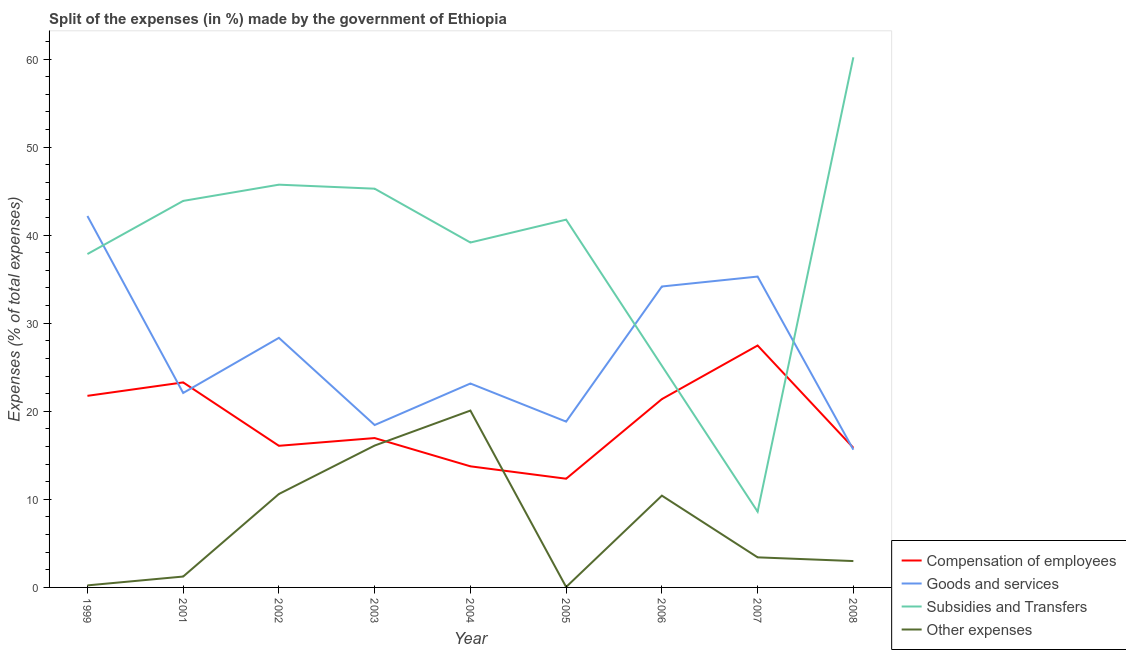Does the line corresponding to percentage of amount spent on goods and services intersect with the line corresponding to percentage of amount spent on compensation of employees?
Provide a succinct answer. Yes. Is the number of lines equal to the number of legend labels?
Your answer should be compact. Yes. What is the percentage of amount spent on compensation of employees in 2002?
Provide a succinct answer. 16.08. Across all years, what is the maximum percentage of amount spent on compensation of employees?
Provide a succinct answer. 27.47. Across all years, what is the minimum percentage of amount spent on compensation of employees?
Offer a very short reply. 12.34. What is the total percentage of amount spent on compensation of employees in the graph?
Your response must be concise. 168.87. What is the difference between the percentage of amount spent on subsidies in 2001 and that in 2004?
Offer a terse response. 4.72. What is the difference between the percentage of amount spent on compensation of employees in 2001 and the percentage of amount spent on other expenses in 2007?
Give a very brief answer. 19.86. What is the average percentage of amount spent on goods and services per year?
Give a very brief answer. 26.46. In the year 2007, what is the difference between the percentage of amount spent on compensation of employees and percentage of amount spent on goods and services?
Offer a terse response. -7.83. In how many years, is the percentage of amount spent on goods and services greater than 6 %?
Your answer should be compact. 9. What is the ratio of the percentage of amount spent on other expenses in 1999 to that in 2005?
Offer a very short reply. 4.73. What is the difference between the highest and the second highest percentage of amount spent on other expenses?
Your answer should be compact. 3.97. What is the difference between the highest and the lowest percentage of amount spent on goods and services?
Give a very brief answer. 26.53. In how many years, is the percentage of amount spent on other expenses greater than the average percentage of amount spent on other expenses taken over all years?
Offer a very short reply. 4. Is it the case that in every year, the sum of the percentage of amount spent on compensation of employees and percentage of amount spent on goods and services is greater than the percentage of amount spent on subsidies?
Your answer should be compact. No. Does the percentage of amount spent on goods and services monotonically increase over the years?
Provide a succinct answer. No. How many lines are there?
Give a very brief answer. 4. Are the values on the major ticks of Y-axis written in scientific E-notation?
Offer a very short reply. No. Does the graph contain grids?
Give a very brief answer. No. Where does the legend appear in the graph?
Make the answer very short. Bottom right. How are the legend labels stacked?
Make the answer very short. Vertical. What is the title of the graph?
Provide a succinct answer. Split of the expenses (in %) made by the government of Ethiopia. Does "Finland" appear as one of the legend labels in the graph?
Provide a succinct answer. No. What is the label or title of the X-axis?
Your response must be concise. Year. What is the label or title of the Y-axis?
Provide a short and direct response. Expenses (% of total expenses). What is the Expenses (% of total expenses) of Compensation of employees in 1999?
Provide a short and direct response. 21.75. What is the Expenses (% of total expenses) in Goods and services in 1999?
Provide a short and direct response. 42.17. What is the Expenses (% of total expenses) in Subsidies and Transfers in 1999?
Your answer should be compact. 37.85. What is the Expenses (% of total expenses) in Other expenses in 1999?
Your response must be concise. 0.23. What is the Expenses (% of total expenses) in Compensation of employees in 2001?
Your answer should be very brief. 23.28. What is the Expenses (% of total expenses) in Goods and services in 2001?
Keep it short and to the point. 22.08. What is the Expenses (% of total expenses) of Subsidies and Transfers in 2001?
Your answer should be very brief. 43.89. What is the Expenses (% of total expenses) in Other expenses in 2001?
Give a very brief answer. 1.24. What is the Expenses (% of total expenses) of Compensation of employees in 2002?
Provide a succinct answer. 16.08. What is the Expenses (% of total expenses) in Goods and services in 2002?
Make the answer very short. 28.34. What is the Expenses (% of total expenses) in Subsidies and Transfers in 2002?
Ensure brevity in your answer.  45.73. What is the Expenses (% of total expenses) in Other expenses in 2002?
Keep it short and to the point. 10.61. What is the Expenses (% of total expenses) of Compensation of employees in 2003?
Offer a very short reply. 16.96. What is the Expenses (% of total expenses) of Goods and services in 2003?
Provide a short and direct response. 18.44. What is the Expenses (% of total expenses) of Subsidies and Transfers in 2003?
Provide a succinct answer. 45.27. What is the Expenses (% of total expenses) of Other expenses in 2003?
Provide a short and direct response. 16.11. What is the Expenses (% of total expenses) of Compensation of employees in 2004?
Ensure brevity in your answer.  13.75. What is the Expenses (% of total expenses) in Goods and services in 2004?
Your response must be concise. 23.15. What is the Expenses (% of total expenses) of Subsidies and Transfers in 2004?
Provide a short and direct response. 39.16. What is the Expenses (% of total expenses) of Other expenses in 2004?
Your response must be concise. 20.08. What is the Expenses (% of total expenses) of Compensation of employees in 2005?
Give a very brief answer. 12.34. What is the Expenses (% of total expenses) in Goods and services in 2005?
Your response must be concise. 18.83. What is the Expenses (% of total expenses) of Subsidies and Transfers in 2005?
Your answer should be compact. 41.76. What is the Expenses (% of total expenses) in Other expenses in 2005?
Offer a very short reply. 0.05. What is the Expenses (% of total expenses) of Compensation of employees in 2006?
Provide a short and direct response. 21.38. What is the Expenses (% of total expenses) of Goods and services in 2006?
Provide a succinct answer. 34.17. What is the Expenses (% of total expenses) of Subsidies and Transfers in 2006?
Ensure brevity in your answer.  25.17. What is the Expenses (% of total expenses) in Other expenses in 2006?
Your answer should be very brief. 10.42. What is the Expenses (% of total expenses) of Compensation of employees in 2007?
Provide a short and direct response. 27.47. What is the Expenses (% of total expenses) of Goods and services in 2007?
Provide a short and direct response. 35.3. What is the Expenses (% of total expenses) in Subsidies and Transfers in 2007?
Your response must be concise. 8.6. What is the Expenses (% of total expenses) in Other expenses in 2007?
Offer a very short reply. 3.42. What is the Expenses (% of total expenses) in Compensation of employees in 2008?
Make the answer very short. 15.85. What is the Expenses (% of total expenses) in Goods and services in 2008?
Make the answer very short. 15.64. What is the Expenses (% of total expenses) in Subsidies and Transfers in 2008?
Your answer should be compact. 60.19. What is the Expenses (% of total expenses) of Other expenses in 2008?
Keep it short and to the point. 2.99. Across all years, what is the maximum Expenses (% of total expenses) in Compensation of employees?
Give a very brief answer. 27.47. Across all years, what is the maximum Expenses (% of total expenses) of Goods and services?
Keep it short and to the point. 42.17. Across all years, what is the maximum Expenses (% of total expenses) of Subsidies and Transfers?
Offer a very short reply. 60.19. Across all years, what is the maximum Expenses (% of total expenses) in Other expenses?
Keep it short and to the point. 20.08. Across all years, what is the minimum Expenses (% of total expenses) of Compensation of employees?
Offer a terse response. 12.34. Across all years, what is the minimum Expenses (% of total expenses) of Goods and services?
Give a very brief answer. 15.64. Across all years, what is the minimum Expenses (% of total expenses) in Subsidies and Transfers?
Your answer should be very brief. 8.6. Across all years, what is the minimum Expenses (% of total expenses) of Other expenses?
Make the answer very short. 0.05. What is the total Expenses (% of total expenses) of Compensation of employees in the graph?
Your response must be concise. 168.87. What is the total Expenses (% of total expenses) in Goods and services in the graph?
Give a very brief answer. 238.12. What is the total Expenses (% of total expenses) in Subsidies and Transfers in the graph?
Keep it short and to the point. 347.63. What is the total Expenses (% of total expenses) of Other expenses in the graph?
Give a very brief answer. 65.15. What is the difference between the Expenses (% of total expenses) of Compensation of employees in 1999 and that in 2001?
Your answer should be very brief. -1.53. What is the difference between the Expenses (% of total expenses) in Goods and services in 1999 and that in 2001?
Keep it short and to the point. 20.09. What is the difference between the Expenses (% of total expenses) of Subsidies and Transfers in 1999 and that in 2001?
Keep it short and to the point. -6.03. What is the difference between the Expenses (% of total expenses) in Other expenses in 1999 and that in 2001?
Offer a very short reply. -1. What is the difference between the Expenses (% of total expenses) of Compensation of employees in 1999 and that in 2002?
Make the answer very short. 5.67. What is the difference between the Expenses (% of total expenses) in Goods and services in 1999 and that in 2002?
Offer a terse response. 13.84. What is the difference between the Expenses (% of total expenses) of Subsidies and Transfers in 1999 and that in 2002?
Keep it short and to the point. -7.88. What is the difference between the Expenses (% of total expenses) in Other expenses in 1999 and that in 2002?
Offer a very short reply. -10.38. What is the difference between the Expenses (% of total expenses) in Compensation of employees in 1999 and that in 2003?
Your answer should be compact. 4.79. What is the difference between the Expenses (% of total expenses) in Goods and services in 1999 and that in 2003?
Give a very brief answer. 23.73. What is the difference between the Expenses (% of total expenses) in Subsidies and Transfers in 1999 and that in 2003?
Your response must be concise. -7.42. What is the difference between the Expenses (% of total expenses) of Other expenses in 1999 and that in 2003?
Offer a terse response. -15.88. What is the difference between the Expenses (% of total expenses) in Compensation of employees in 1999 and that in 2004?
Keep it short and to the point. 8. What is the difference between the Expenses (% of total expenses) in Goods and services in 1999 and that in 2004?
Keep it short and to the point. 19.02. What is the difference between the Expenses (% of total expenses) in Subsidies and Transfers in 1999 and that in 2004?
Offer a terse response. -1.31. What is the difference between the Expenses (% of total expenses) of Other expenses in 1999 and that in 2004?
Give a very brief answer. -19.85. What is the difference between the Expenses (% of total expenses) of Compensation of employees in 1999 and that in 2005?
Your answer should be compact. 9.41. What is the difference between the Expenses (% of total expenses) in Goods and services in 1999 and that in 2005?
Offer a very short reply. 23.35. What is the difference between the Expenses (% of total expenses) of Subsidies and Transfers in 1999 and that in 2005?
Ensure brevity in your answer.  -3.91. What is the difference between the Expenses (% of total expenses) of Other expenses in 1999 and that in 2005?
Provide a short and direct response. 0.18. What is the difference between the Expenses (% of total expenses) in Compensation of employees in 1999 and that in 2006?
Give a very brief answer. 0.37. What is the difference between the Expenses (% of total expenses) in Goods and services in 1999 and that in 2006?
Your response must be concise. 8. What is the difference between the Expenses (% of total expenses) of Subsidies and Transfers in 1999 and that in 2006?
Your answer should be very brief. 12.69. What is the difference between the Expenses (% of total expenses) in Other expenses in 1999 and that in 2006?
Keep it short and to the point. -10.19. What is the difference between the Expenses (% of total expenses) in Compensation of employees in 1999 and that in 2007?
Make the answer very short. -5.71. What is the difference between the Expenses (% of total expenses) of Goods and services in 1999 and that in 2007?
Your answer should be very brief. 6.88. What is the difference between the Expenses (% of total expenses) in Subsidies and Transfers in 1999 and that in 2007?
Provide a succinct answer. 29.25. What is the difference between the Expenses (% of total expenses) of Other expenses in 1999 and that in 2007?
Offer a terse response. -3.18. What is the difference between the Expenses (% of total expenses) in Compensation of employees in 1999 and that in 2008?
Your response must be concise. 5.9. What is the difference between the Expenses (% of total expenses) of Goods and services in 1999 and that in 2008?
Provide a short and direct response. 26.53. What is the difference between the Expenses (% of total expenses) of Subsidies and Transfers in 1999 and that in 2008?
Your answer should be compact. -22.34. What is the difference between the Expenses (% of total expenses) in Other expenses in 1999 and that in 2008?
Your response must be concise. -2.76. What is the difference between the Expenses (% of total expenses) of Compensation of employees in 2001 and that in 2002?
Offer a terse response. 7.2. What is the difference between the Expenses (% of total expenses) of Goods and services in 2001 and that in 2002?
Provide a succinct answer. -6.26. What is the difference between the Expenses (% of total expenses) of Subsidies and Transfers in 2001 and that in 2002?
Provide a succinct answer. -1.84. What is the difference between the Expenses (% of total expenses) in Other expenses in 2001 and that in 2002?
Give a very brief answer. -9.37. What is the difference between the Expenses (% of total expenses) of Compensation of employees in 2001 and that in 2003?
Give a very brief answer. 6.32. What is the difference between the Expenses (% of total expenses) of Goods and services in 2001 and that in 2003?
Your response must be concise. 3.64. What is the difference between the Expenses (% of total expenses) in Subsidies and Transfers in 2001 and that in 2003?
Your answer should be compact. -1.39. What is the difference between the Expenses (% of total expenses) of Other expenses in 2001 and that in 2003?
Provide a short and direct response. -14.87. What is the difference between the Expenses (% of total expenses) in Compensation of employees in 2001 and that in 2004?
Provide a succinct answer. 9.53. What is the difference between the Expenses (% of total expenses) in Goods and services in 2001 and that in 2004?
Your answer should be compact. -1.07. What is the difference between the Expenses (% of total expenses) in Subsidies and Transfers in 2001 and that in 2004?
Offer a very short reply. 4.72. What is the difference between the Expenses (% of total expenses) in Other expenses in 2001 and that in 2004?
Your response must be concise. -18.84. What is the difference between the Expenses (% of total expenses) of Compensation of employees in 2001 and that in 2005?
Your response must be concise. 10.94. What is the difference between the Expenses (% of total expenses) of Goods and services in 2001 and that in 2005?
Offer a very short reply. 3.25. What is the difference between the Expenses (% of total expenses) of Subsidies and Transfers in 2001 and that in 2005?
Give a very brief answer. 2.13. What is the difference between the Expenses (% of total expenses) in Other expenses in 2001 and that in 2005?
Offer a terse response. 1.19. What is the difference between the Expenses (% of total expenses) of Compensation of employees in 2001 and that in 2006?
Provide a short and direct response. 1.9. What is the difference between the Expenses (% of total expenses) of Goods and services in 2001 and that in 2006?
Provide a succinct answer. -12.09. What is the difference between the Expenses (% of total expenses) of Subsidies and Transfers in 2001 and that in 2006?
Provide a short and direct response. 18.72. What is the difference between the Expenses (% of total expenses) in Other expenses in 2001 and that in 2006?
Your answer should be very brief. -9.19. What is the difference between the Expenses (% of total expenses) in Compensation of employees in 2001 and that in 2007?
Offer a terse response. -4.19. What is the difference between the Expenses (% of total expenses) in Goods and services in 2001 and that in 2007?
Provide a succinct answer. -13.22. What is the difference between the Expenses (% of total expenses) in Subsidies and Transfers in 2001 and that in 2007?
Offer a terse response. 35.28. What is the difference between the Expenses (% of total expenses) in Other expenses in 2001 and that in 2007?
Make the answer very short. -2.18. What is the difference between the Expenses (% of total expenses) of Compensation of employees in 2001 and that in 2008?
Your response must be concise. 7.43. What is the difference between the Expenses (% of total expenses) of Goods and services in 2001 and that in 2008?
Provide a short and direct response. 6.44. What is the difference between the Expenses (% of total expenses) of Subsidies and Transfers in 2001 and that in 2008?
Give a very brief answer. -16.31. What is the difference between the Expenses (% of total expenses) of Other expenses in 2001 and that in 2008?
Your response must be concise. -1.76. What is the difference between the Expenses (% of total expenses) of Compensation of employees in 2002 and that in 2003?
Make the answer very short. -0.88. What is the difference between the Expenses (% of total expenses) in Goods and services in 2002 and that in 2003?
Your response must be concise. 9.9. What is the difference between the Expenses (% of total expenses) of Subsidies and Transfers in 2002 and that in 2003?
Your answer should be very brief. 0.46. What is the difference between the Expenses (% of total expenses) of Other expenses in 2002 and that in 2003?
Your answer should be very brief. -5.5. What is the difference between the Expenses (% of total expenses) in Compensation of employees in 2002 and that in 2004?
Offer a very short reply. 2.33. What is the difference between the Expenses (% of total expenses) in Goods and services in 2002 and that in 2004?
Provide a short and direct response. 5.18. What is the difference between the Expenses (% of total expenses) in Subsidies and Transfers in 2002 and that in 2004?
Your response must be concise. 6.57. What is the difference between the Expenses (% of total expenses) of Other expenses in 2002 and that in 2004?
Provide a short and direct response. -9.47. What is the difference between the Expenses (% of total expenses) in Compensation of employees in 2002 and that in 2005?
Provide a succinct answer. 3.74. What is the difference between the Expenses (% of total expenses) in Goods and services in 2002 and that in 2005?
Your answer should be very brief. 9.51. What is the difference between the Expenses (% of total expenses) of Subsidies and Transfers in 2002 and that in 2005?
Your answer should be compact. 3.97. What is the difference between the Expenses (% of total expenses) in Other expenses in 2002 and that in 2005?
Give a very brief answer. 10.56. What is the difference between the Expenses (% of total expenses) in Compensation of employees in 2002 and that in 2006?
Provide a succinct answer. -5.3. What is the difference between the Expenses (% of total expenses) in Goods and services in 2002 and that in 2006?
Your answer should be very brief. -5.83. What is the difference between the Expenses (% of total expenses) of Subsidies and Transfers in 2002 and that in 2006?
Keep it short and to the point. 20.56. What is the difference between the Expenses (% of total expenses) in Other expenses in 2002 and that in 2006?
Your response must be concise. 0.19. What is the difference between the Expenses (% of total expenses) in Compensation of employees in 2002 and that in 2007?
Make the answer very short. -11.39. What is the difference between the Expenses (% of total expenses) in Goods and services in 2002 and that in 2007?
Ensure brevity in your answer.  -6.96. What is the difference between the Expenses (% of total expenses) in Subsidies and Transfers in 2002 and that in 2007?
Your answer should be compact. 37.13. What is the difference between the Expenses (% of total expenses) in Other expenses in 2002 and that in 2007?
Offer a very short reply. 7.19. What is the difference between the Expenses (% of total expenses) of Compensation of employees in 2002 and that in 2008?
Offer a very short reply. 0.23. What is the difference between the Expenses (% of total expenses) of Goods and services in 2002 and that in 2008?
Give a very brief answer. 12.7. What is the difference between the Expenses (% of total expenses) in Subsidies and Transfers in 2002 and that in 2008?
Provide a short and direct response. -14.46. What is the difference between the Expenses (% of total expenses) of Other expenses in 2002 and that in 2008?
Your answer should be very brief. 7.62. What is the difference between the Expenses (% of total expenses) of Compensation of employees in 2003 and that in 2004?
Offer a very short reply. 3.21. What is the difference between the Expenses (% of total expenses) of Goods and services in 2003 and that in 2004?
Make the answer very short. -4.71. What is the difference between the Expenses (% of total expenses) of Subsidies and Transfers in 2003 and that in 2004?
Offer a very short reply. 6.11. What is the difference between the Expenses (% of total expenses) of Other expenses in 2003 and that in 2004?
Make the answer very short. -3.97. What is the difference between the Expenses (% of total expenses) of Compensation of employees in 2003 and that in 2005?
Your answer should be very brief. 4.62. What is the difference between the Expenses (% of total expenses) in Goods and services in 2003 and that in 2005?
Give a very brief answer. -0.39. What is the difference between the Expenses (% of total expenses) of Subsidies and Transfers in 2003 and that in 2005?
Your response must be concise. 3.51. What is the difference between the Expenses (% of total expenses) in Other expenses in 2003 and that in 2005?
Your response must be concise. 16.06. What is the difference between the Expenses (% of total expenses) in Compensation of employees in 2003 and that in 2006?
Your response must be concise. -4.42. What is the difference between the Expenses (% of total expenses) of Goods and services in 2003 and that in 2006?
Ensure brevity in your answer.  -15.73. What is the difference between the Expenses (% of total expenses) of Subsidies and Transfers in 2003 and that in 2006?
Ensure brevity in your answer.  20.11. What is the difference between the Expenses (% of total expenses) of Other expenses in 2003 and that in 2006?
Provide a succinct answer. 5.69. What is the difference between the Expenses (% of total expenses) of Compensation of employees in 2003 and that in 2007?
Provide a succinct answer. -10.51. What is the difference between the Expenses (% of total expenses) of Goods and services in 2003 and that in 2007?
Make the answer very short. -16.86. What is the difference between the Expenses (% of total expenses) in Subsidies and Transfers in 2003 and that in 2007?
Offer a terse response. 36.67. What is the difference between the Expenses (% of total expenses) in Other expenses in 2003 and that in 2007?
Provide a short and direct response. 12.69. What is the difference between the Expenses (% of total expenses) in Compensation of employees in 2003 and that in 2008?
Your response must be concise. 1.11. What is the difference between the Expenses (% of total expenses) of Goods and services in 2003 and that in 2008?
Your response must be concise. 2.8. What is the difference between the Expenses (% of total expenses) of Subsidies and Transfers in 2003 and that in 2008?
Give a very brief answer. -14.92. What is the difference between the Expenses (% of total expenses) of Other expenses in 2003 and that in 2008?
Your answer should be compact. 13.12. What is the difference between the Expenses (% of total expenses) in Compensation of employees in 2004 and that in 2005?
Keep it short and to the point. 1.41. What is the difference between the Expenses (% of total expenses) in Goods and services in 2004 and that in 2005?
Give a very brief answer. 4.33. What is the difference between the Expenses (% of total expenses) in Subsidies and Transfers in 2004 and that in 2005?
Ensure brevity in your answer.  -2.6. What is the difference between the Expenses (% of total expenses) in Other expenses in 2004 and that in 2005?
Your answer should be very brief. 20.03. What is the difference between the Expenses (% of total expenses) of Compensation of employees in 2004 and that in 2006?
Keep it short and to the point. -7.63. What is the difference between the Expenses (% of total expenses) in Goods and services in 2004 and that in 2006?
Your answer should be very brief. -11.02. What is the difference between the Expenses (% of total expenses) of Subsidies and Transfers in 2004 and that in 2006?
Make the answer very short. 14. What is the difference between the Expenses (% of total expenses) in Other expenses in 2004 and that in 2006?
Give a very brief answer. 9.66. What is the difference between the Expenses (% of total expenses) in Compensation of employees in 2004 and that in 2007?
Make the answer very short. -13.72. What is the difference between the Expenses (% of total expenses) of Goods and services in 2004 and that in 2007?
Your answer should be very brief. -12.14. What is the difference between the Expenses (% of total expenses) of Subsidies and Transfers in 2004 and that in 2007?
Make the answer very short. 30.56. What is the difference between the Expenses (% of total expenses) of Other expenses in 2004 and that in 2007?
Your response must be concise. 16.66. What is the difference between the Expenses (% of total expenses) of Compensation of employees in 2004 and that in 2008?
Offer a terse response. -2.1. What is the difference between the Expenses (% of total expenses) in Goods and services in 2004 and that in 2008?
Provide a succinct answer. 7.51. What is the difference between the Expenses (% of total expenses) of Subsidies and Transfers in 2004 and that in 2008?
Ensure brevity in your answer.  -21.03. What is the difference between the Expenses (% of total expenses) in Other expenses in 2004 and that in 2008?
Provide a succinct answer. 17.09. What is the difference between the Expenses (% of total expenses) of Compensation of employees in 2005 and that in 2006?
Offer a terse response. -9.04. What is the difference between the Expenses (% of total expenses) in Goods and services in 2005 and that in 2006?
Offer a terse response. -15.34. What is the difference between the Expenses (% of total expenses) of Subsidies and Transfers in 2005 and that in 2006?
Make the answer very short. 16.59. What is the difference between the Expenses (% of total expenses) in Other expenses in 2005 and that in 2006?
Your answer should be compact. -10.37. What is the difference between the Expenses (% of total expenses) in Compensation of employees in 2005 and that in 2007?
Your answer should be compact. -15.13. What is the difference between the Expenses (% of total expenses) of Goods and services in 2005 and that in 2007?
Offer a very short reply. -16.47. What is the difference between the Expenses (% of total expenses) in Subsidies and Transfers in 2005 and that in 2007?
Make the answer very short. 33.15. What is the difference between the Expenses (% of total expenses) of Other expenses in 2005 and that in 2007?
Make the answer very short. -3.37. What is the difference between the Expenses (% of total expenses) in Compensation of employees in 2005 and that in 2008?
Make the answer very short. -3.51. What is the difference between the Expenses (% of total expenses) in Goods and services in 2005 and that in 2008?
Give a very brief answer. 3.19. What is the difference between the Expenses (% of total expenses) in Subsidies and Transfers in 2005 and that in 2008?
Your response must be concise. -18.43. What is the difference between the Expenses (% of total expenses) of Other expenses in 2005 and that in 2008?
Your answer should be very brief. -2.94. What is the difference between the Expenses (% of total expenses) in Compensation of employees in 2006 and that in 2007?
Offer a very short reply. -6.09. What is the difference between the Expenses (% of total expenses) of Goods and services in 2006 and that in 2007?
Offer a very short reply. -1.13. What is the difference between the Expenses (% of total expenses) of Subsidies and Transfers in 2006 and that in 2007?
Your answer should be very brief. 16.56. What is the difference between the Expenses (% of total expenses) in Other expenses in 2006 and that in 2007?
Provide a succinct answer. 7.01. What is the difference between the Expenses (% of total expenses) of Compensation of employees in 2006 and that in 2008?
Give a very brief answer. 5.53. What is the difference between the Expenses (% of total expenses) in Goods and services in 2006 and that in 2008?
Offer a terse response. 18.53. What is the difference between the Expenses (% of total expenses) of Subsidies and Transfers in 2006 and that in 2008?
Provide a succinct answer. -35.03. What is the difference between the Expenses (% of total expenses) in Other expenses in 2006 and that in 2008?
Offer a terse response. 7.43. What is the difference between the Expenses (% of total expenses) of Compensation of employees in 2007 and that in 2008?
Your response must be concise. 11.62. What is the difference between the Expenses (% of total expenses) in Goods and services in 2007 and that in 2008?
Keep it short and to the point. 19.65. What is the difference between the Expenses (% of total expenses) in Subsidies and Transfers in 2007 and that in 2008?
Make the answer very short. -51.59. What is the difference between the Expenses (% of total expenses) in Other expenses in 2007 and that in 2008?
Your answer should be compact. 0.42. What is the difference between the Expenses (% of total expenses) in Compensation of employees in 1999 and the Expenses (% of total expenses) in Goods and services in 2001?
Your response must be concise. -0.33. What is the difference between the Expenses (% of total expenses) of Compensation of employees in 1999 and the Expenses (% of total expenses) of Subsidies and Transfers in 2001?
Your answer should be very brief. -22.13. What is the difference between the Expenses (% of total expenses) of Compensation of employees in 1999 and the Expenses (% of total expenses) of Other expenses in 2001?
Your answer should be compact. 20.52. What is the difference between the Expenses (% of total expenses) of Goods and services in 1999 and the Expenses (% of total expenses) of Subsidies and Transfers in 2001?
Ensure brevity in your answer.  -1.71. What is the difference between the Expenses (% of total expenses) in Goods and services in 1999 and the Expenses (% of total expenses) in Other expenses in 2001?
Your answer should be compact. 40.94. What is the difference between the Expenses (% of total expenses) of Subsidies and Transfers in 1999 and the Expenses (% of total expenses) of Other expenses in 2001?
Your response must be concise. 36.62. What is the difference between the Expenses (% of total expenses) of Compensation of employees in 1999 and the Expenses (% of total expenses) of Goods and services in 2002?
Ensure brevity in your answer.  -6.58. What is the difference between the Expenses (% of total expenses) in Compensation of employees in 1999 and the Expenses (% of total expenses) in Subsidies and Transfers in 2002?
Offer a terse response. -23.98. What is the difference between the Expenses (% of total expenses) of Compensation of employees in 1999 and the Expenses (% of total expenses) of Other expenses in 2002?
Your response must be concise. 11.15. What is the difference between the Expenses (% of total expenses) in Goods and services in 1999 and the Expenses (% of total expenses) in Subsidies and Transfers in 2002?
Your answer should be very brief. -3.56. What is the difference between the Expenses (% of total expenses) of Goods and services in 1999 and the Expenses (% of total expenses) of Other expenses in 2002?
Offer a very short reply. 31.56. What is the difference between the Expenses (% of total expenses) in Subsidies and Transfers in 1999 and the Expenses (% of total expenses) in Other expenses in 2002?
Your answer should be compact. 27.24. What is the difference between the Expenses (% of total expenses) of Compensation of employees in 1999 and the Expenses (% of total expenses) of Goods and services in 2003?
Ensure brevity in your answer.  3.31. What is the difference between the Expenses (% of total expenses) of Compensation of employees in 1999 and the Expenses (% of total expenses) of Subsidies and Transfers in 2003?
Make the answer very short. -23.52. What is the difference between the Expenses (% of total expenses) of Compensation of employees in 1999 and the Expenses (% of total expenses) of Other expenses in 2003?
Your answer should be very brief. 5.64. What is the difference between the Expenses (% of total expenses) in Goods and services in 1999 and the Expenses (% of total expenses) in Subsidies and Transfers in 2003?
Your response must be concise. -3.1. What is the difference between the Expenses (% of total expenses) in Goods and services in 1999 and the Expenses (% of total expenses) in Other expenses in 2003?
Provide a succinct answer. 26.06. What is the difference between the Expenses (% of total expenses) in Subsidies and Transfers in 1999 and the Expenses (% of total expenses) in Other expenses in 2003?
Offer a very short reply. 21.74. What is the difference between the Expenses (% of total expenses) of Compensation of employees in 1999 and the Expenses (% of total expenses) of Subsidies and Transfers in 2004?
Your answer should be very brief. -17.41. What is the difference between the Expenses (% of total expenses) of Compensation of employees in 1999 and the Expenses (% of total expenses) of Other expenses in 2004?
Give a very brief answer. 1.67. What is the difference between the Expenses (% of total expenses) of Goods and services in 1999 and the Expenses (% of total expenses) of Subsidies and Transfers in 2004?
Offer a very short reply. 3.01. What is the difference between the Expenses (% of total expenses) in Goods and services in 1999 and the Expenses (% of total expenses) in Other expenses in 2004?
Offer a very short reply. 22.09. What is the difference between the Expenses (% of total expenses) of Subsidies and Transfers in 1999 and the Expenses (% of total expenses) of Other expenses in 2004?
Keep it short and to the point. 17.77. What is the difference between the Expenses (% of total expenses) in Compensation of employees in 1999 and the Expenses (% of total expenses) in Goods and services in 2005?
Ensure brevity in your answer.  2.93. What is the difference between the Expenses (% of total expenses) of Compensation of employees in 1999 and the Expenses (% of total expenses) of Subsidies and Transfers in 2005?
Make the answer very short. -20.01. What is the difference between the Expenses (% of total expenses) in Compensation of employees in 1999 and the Expenses (% of total expenses) in Other expenses in 2005?
Give a very brief answer. 21.7. What is the difference between the Expenses (% of total expenses) of Goods and services in 1999 and the Expenses (% of total expenses) of Subsidies and Transfers in 2005?
Offer a very short reply. 0.41. What is the difference between the Expenses (% of total expenses) in Goods and services in 1999 and the Expenses (% of total expenses) in Other expenses in 2005?
Your answer should be compact. 42.12. What is the difference between the Expenses (% of total expenses) in Subsidies and Transfers in 1999 and the Expenses (% of total expenses) in Other expenses in 2005?
Your response must be concise. 37.8. What is the difference between the Expenses (% of total expenses) of Compensation of employees in 1999 and the Expenses (% of total expenses) of Goods and services in 2006?
Give a very brief answer. -12.42. What is the difference between the Expenses (% of total expenses) of Compensation of employees in 1999 and the Expenses (% of total expenses) of Subsidies and Transfers in 2006?
Give a very brief answer. -3.41. What is the difference between the Expenses (% of total expenses) of Compensation of employees in 1999 and the Expenses (% of total expenses) of Other expenses in 2006?
Give a very brief answer. 11.33. What is the difference between the Expenses (% of total expenses) in Goods and services in 1999 and the Expenses (% of total expenses) in Subsidies and Transfers in 2006?
Offer a terse response. 17.01. What is the difference between the Expenses (% of total expenses) of Goods and services in 1999 and the Expenses (% of total expenses) of Other expenses in 2006?
Provide a short and direct response. 31.75. What is the difference between the Expenses (% of total expenses) in Subsidies and Transfers in 1999 and the Expenses (% of total expenses) in Other expenses in 2006?
Provide a short and direct response. 27.43. What is the difference between the Expenses (% of total expenses) in Compensation of employees in 1999 and the Expenses (% of total expenses) in Goods and services in 2007?
Offer a terse response. -13.54. What is the difference between the Expenses (% of total expenses) in Compensation of employees in 1999 and the Expenses (% of total expenses) in Subsidies and Transfers in 2007?
Provide a succinct answer. 13.15. What is the difference between the Expenses (% of total expenses) of Compensation of employees in 1999 and the Expenses (% of total expenses) of Other expenses in 2007?
Offer a terse response. 18.34. What is the difference between the Expenses (% of total expenses) of Goods and services in 1999 and the Expenses (% of total expenses) of Subsidies and Transfers in 2007?
Provide a short and direct response. 33.57. What is the difference between the Expenses (% of total expenses) of Goods and services in 1999 and the Expenses (% of total expenses) of Other expenses in 2007?
Ensure brevity in your answer.  38.76. What is the difference between the Expenses (% of total expenses) in Subsidies and Transfers in 1999 and the Expenses (% of total expenses) in Other expenses in 2007?
Offer a very short reply. 34.44. What is the difference between the Expenses (% of total expenses) of Compensation of employees in 1999 and the Expenses (% of total expenses) of Goods and services in 2008?
Offer a terse response. 6.11. What is the difference between the Expenses (% of total expenses) of Compensation of employees in 1999 and the Expenses (% of total expenses) of Subsidies and Transfers in 2008?
Keep it short and to the point. -38.44. What is the difference between the Expenses (% of total expenses) of Compensation of employees in 1999 and the Expenses (% of total expenses) of Other expenses in 2008?
Offer a terse response. 18.76. What is the difference between the Expenses (% of total expenses) in Goods and services in 1999 and the Expenses (% of total expenses) in Subsidies and Transfers in 2008?
Provide a short and direct response. -18.02. What is the difference between the Expenses (% of total expenses) in Goods and services in 1999 and the Expenses (% of total expenses) in Other expenses in 2008?
Provide a short and direct response. 39.18. What is the difference between the Expenses (% of total expenses) in Subsidies and Transfers in 1999 and the Expenses (% of total expenses) in Other expenses in 2008?
Offer a very short reply. 34.86. What is the difference between the Expenses (% of total expenses) in Compensation of employees in 2001 and the Expenses (% of total expenses) in Goods and services in 2002?
Keep it short and to the point. -5.06. What is the difference between the Expenses (% of total expenses) in Compensation of employees in 2001 and the Expenses (% of total expenses) in Subsidies and Transfers in 2002?
Provide a short and direct response. -22.45. What is the difference between the Expenses (% of total expenses) in Compensation of employees in 2001 and the Expenses (% of total expenses) in Other expenses in 2002?
Provide a short and direct response. 12.67. What is the difference between the Expenses (% of total expenses) of Goods and services in 2001 and the Expenses (% of total expenses) of Subsidies and Transfers in 2002?
Provide a short and direct response. -23.65. What is the difference between the Expenses (% of total expenses) in Goods and services in 2001 and the Expenses (% of total expenses) in Other expenses in 2002?
Your answer should be compact. 11.47. What is the difference between the Expenses (% of total expenses) of Subsidies and Transfers in 2001 and the Expenses (% of total expenses) of Other expenses in 2002?
Provide a succinct answer. 33.28. What is the difference between the Expenses (% of total expenses) in Compensation of employees in 2001 and the Expenses (% of total expenses) in Goods and services in 2003?
Give a very brief answer. 4.84. What is the difference between the Expenses (% of total expenses) in Compensation of employees in 2001 and the Expenses (% of total expenses) in Subsidies and Transfers in 2003?
Make the answer very short. -22. What is the difference between the Expenses (% of total expenses) in Compensation of employees in 2001 and the Expenses (% of total expenses) in Other expenses in 2003?
Provide a short and direct response. 7.17. What is the difference between the Expenses (% of total expenses) in Goods and services in 2001 and the Expenses (% of total expenses) in Subsidies and Transfers in 2003?
Keep it short and to the point. -23.2. What is the difference between the Expenses (% of total expenses) of Goods and services in 2001 and the Expenses (% of total expenses) of Other expenses in 2003?
Give a very brief answer. 5.97. What is the difference between the Expenses (% of total expenses) in Subsidies and Transfers in 2001 and the Expenses (% of total expenses) in Other expenses in 2003?
Ensure brevity in your answer.  27.78. What is the difference between the Expenses (% of total expenses) of Compensation of employees in 2001 and the Expenses (% of total expenses) of Goods and services in 2004?
Your answer should be very brief. 0.13. What is the difference between the Expenses (% of total expenses) in Compensation of employees in 2001 and the Expenses (% of total expenses) in Subsidies and Transfers in 2004?
Keep it short and to the point. -15.88. What is the difference between the Expenses (% of total expenses) in Compensation of employees in 2001 and the Expenses (% of total expenses) in Other expenses in 2004?
Offer a very short reply. 3.2. What is the difference between the Expenses (% of total expenses) in Goods and services in 2001 and the Expenses (% of total expenses) in Subsidies and Transfers in 2004?
Your answer should be very brief. -17.08. What is the difference between the Expenses (% of total expenses) in Goods and services in 2001 and the Expenses (% of total expenses) in Other expenses in 2004?
Your answer should be compact. 2. What is the difference between the Expenses (% of total expenses) of Subsidies and Transfers in 2001 and the Expenses (% of total expenses) of Other expenses in 2004?
Your response must be concise. 23.81. What is the difference between the Expenses (% of total expenses) in Compensation of employees in 2001 and the Expenses (% of total expenses) in Goods and services in 2005?
Keep it short and to the point. 4.45. What is the difference between the Expenses (% of total expenses) in Compensation of employees in 2001 and the Expenses (% of total expenses) in Subsidies and Transfers in 2005?
Provide a succinct answer. -18.48. What is the difference between the Expenses (% of total expenses) of Compensation of employees in 2001 and the Expenses (% of total expenses) of Other expenses in 2005?
Offer a very short reply. 23.23. What is the difference between the Expenses (% of total expenses) in Goods and services in 2001 and the Expenses (% of total expenses) in Subsidies and Transfers in 2005?
Keep it short and to the point. -19.68. What is the difference between the Expenses (% of total expenses) in Goods and services in 2001 and the Expenses (% of total expenses) in Other expenses in 2005?
Give a very brief answer. 22.03. What is the difference between the Expenses (% of total expenses) in Subsidies and Transfers in 2001 and the Expenses (% of total expenses) in Other expenses in 2005?
Your answer should be compact. 43.84. What is the difference between the Expenses (% of total expenses) of Compensation of employees in 2001 and the Expenses (% of total expenses) of Goods and services in 2006?
Give a very brief answer. -10.89. What is the difference between the Expenses (% of total expenses) in Compensation of employees in 2001 and the Expenses (% of total expenses) in Subsidies and Transfers in 2006?
Make the answer very short. -1.89. What is the difference between the Expenses (% of total expenses) in Compensation of employees in 2001 and the Expenses (% of total expenses) in Other expenses in 2006?
Ensure brevity in your answer.  12.86. What is the difference between the Expenses (% of total expenses) in Goods and services in 2001 and the Expenses (% of total expenses) in Subsidies and Transfers in 2006?
Make the answer very short. -3.09. What is the difference between the Expenses (% of total expenses) of Goods and services in 2001 and the Expenses (% of total expenses) of Other expenses in 2006?
Provide a succinct answer. 11.66. What is the difference between the Expenses (% of total expenses) of Subsidies and Transfers in 2001 and the Expenses (% of total expenses) of Other expenses in 2006?
Make the answer very short. 33.47. What is the difference between the Expenses (% of total expenses) of Compensation of employees in 2001 and the Expenses (% of total expenses) of Goods and services in 2007?
Ensure brevity in your answer.  -12.02. What is the difference between the Expenses (% of total expenses) of Compensation of employees in 2001 and the Expenses (% of total expenses) of Subsidies and Transfers in 2007?
Offer a very short reply. 14.67. What is the difference between the Expenses (% of total expenses) of Compensation of employees in 2001 and the Expenses (% of total expenses) of Other expenses in 2007?
Ensure brevity in your answer.  19.86. What is the difference between the Expenses (% of total expenses) of Goods and services in 2001 and the Expenses (% of total expenses) of Subsidies and Transfers in 2007?
Ensure brevity in your answer.  13.47. What is the difference between the Expenses (% of total expenses) in Goods and services in 2001 and the Expenses (% of total expenses) in Other expenses in 2007?
Provide a succinct answer. 18.66. What is the difference between the Expenses (% of total expenses) in Subsidies and Transfers in 2001 and the Expenses (% of total expenses) in Other expenses in 2007?
Provide a short and direct response. 40.47. What is the difference between the Expenses (% of total expenses) of Compensation of employees in 2001 and the Expenses (% of total expenses) of Goods and services in 2008?
Make the answer very short. 7.64. What is the difference between the Expenses (% of total expenses) in Compensation of employees in 2001 and the Expenses (% of total expenses) in Subsidies and Transfers in 2008?
Give a very brief answer. -36.91. What is the difference between the Expenses (% of total expenses) of Compensation of employees in 2001 and the Expenses (% of total expenses) of Other expenses in 2008?
Provide a succinct answer. 20.29. What is the difference between the Expenses (% of total expenses) of Goods and services in 2001 and the Expenses (% of total expenses) of Subsidies and Transfers in 2008?
Ensure brevity in your answer.  -38.11. What is the difference between the Expenses (% of total expenses) of Goods and services in 2001 and the Expenses (% of total expenses) of Other expenses in 2008?
Make the answer very short. 19.09. What is the difference between the Expenses (% of total expenses) in Subsidies and Transfers in 2001 and the Expenses (% of total expenses) in Other expenses in 2008?
Your answer should be compact. 40.89. What is the difference between the Expenses (% of total expenses) in Compensation of employees in 2002 and the Expenses (% of total expenses) in Goods and services in 2003?
Keep it short and to the point. -2.36. What is the difference between the Expenses (% of total expenses) in Compensation of employees in 2002 and the Expenses (% of total expenses) in Subsidies and Transfers in 2003?
Your response must be concise. -29.19. What is the difference between the Expenses (% of total expenses) in Compensation of employees in 2002 and the Expenses (% of total expenses) in Other expenses in 2003?
Your response must be concise. -0.03. What is the difference between the Expenses (% of total expenses) of Goods and services in 2002 and the Expenses (% of total expenses) of Subsidies and Transfers in 2003?
Offer a very short reply. -16.94. What is the difference between the Expenses (% of total expenses) in Goods and services in 2002 and the Expenses (% of total expenses) in Other expenses in 2003?
Your answer should be compact. 12.23. What is the difference between the Expenses (% of total expenses) of Subsidies and Transfers in 2002 and the Expenses (% of total expenses) of Other expenses in 2003?
Give a very brief answer. 29.62. What is the difference between the Expenses (% of total expenses) of Compensation of employees in 2002 and the Expenses (% of total expenses) of Goods and services in 2004?
Provide a succinct answer. -7.07. What is the difference between the Expenses (% of total expenses) of Compensation of employees in 2002 and the Expenses (% of total expenses) of Subsidies and Transfers in 2004?
Your response must be concise. -23.08. What is the difference between the Expenses (% of total expenses) of Compensation of employees in 2002 and the Expenses (% of total expenses) of Other expenses in 2004?
Offer a terse response. -4. What is the difference between the Expenses (% of total expenses) in Goods and services in 2002 and the Expenses (% of total expenses) in Subsidies and Transfers in 2004?
Your response must be concise. -10.82. What is the difference between the Expenses (% of total expenses) in Goods and services in 2002 and the Expenses (% of total expenses) in Other expenses in 2004?
Your answer should be very brief. 8.26. What is the difference between the Expenses (% of total expenses) of Subsidies and Transfers in 2002 and the Expenses (% of total expenses) of Other expenses in 2004?
Keep it short and to the point. 25.65. What is the difference between the Expenses (% of total expenses) in Compensation of employees in 2002 and the Expenses (% of total expenses) in Goods and services in 2005?
Offer a very short reply. -2.75. What is the difference between the Expenses (% of total expenses) of Compensation of employees in 2002 and the Expenses (% of total expenses) of Subsidies and Transfers in 2005?
Your response must be concise. -25.68. What is the difference between the Expenses (% of total expenses) in Compensation of employees in 2002 and the Expenses (% of total expenses) in Other expenses in 2005?
Make the answer very short. 16.03. What is the difference between the Expenses (% of total expenses) of Goods and services in 2002 and the Expenses (% of total expenses) of Subsidies and Transfers in 2005?
Offer a terse response. -13.42. What is the difference between the Expenses (% of total expenses) of Goods and services in 2002 and the Expenses (% of total expenses) of Other expenses in 2005?
Offer a very short reply. 28.29. What is the difference between the Expenses (% of total expenses) in Subsidies and Transfers in 2002 and the Expenses (% of total expenses) in Other expenses in 2005?
Your answer should be very brief. 45.68. What is the difference between the Expenses (% of total expenses) of Compensation of employees in 2002 and the Expenses (% of total expenses) of Goods and services in 2006?
Offer a terse response. -18.09. What is the difference between the Expenses (% of total expenses) of Compensation of employees in 2002 and the Expenses (% of total expenses) of Subsidies and Transfers in 2006?
Provide a succinct answer. -9.08. What is the difference between the Expenses (% of total expenses) in Compensation of employees in 2002 and the Expenses (% of total expenses) in Other expenses in 2006?
Offer a very short reply. 5.66. What is the difference between the Expenses (% of total expenses) in Goods and services in 2002 and the Expenses (% of total expenses) in Subsidies and Transfers in 2006?
Give a very brief answer. 3.17. What is the difference between the Expenses (% of total expenses) of Goods and services in 2002 and the Expenses (% of total expenses) of Other expenses in 2006?
Your response must be concise. 17.92. What is the difference between the Expenses (% of total expenses) in Subsidies and Transfers in 2002 and the Expenses (% of total expenses) in Other expenses in 2006?
Keep it short and to the point. 35.31. What is the difference between the Expenses (% of total expenses) in Compensation of employees in 2002 and the Expenses (% of total expenses) in Goods and services in 2007?
Your answer should be very brief. -19.22. What is the difference between the Expenses (% of total expenses) of Compensation of employees in 2002 and the Expenses (% of total expenses) of Subsidies and Transfers in 2007?
Provide a succinct answer. 7.48. What is the difference between the Expenses (% of total expenses) in Compensation of employees in 2002 and the Expenses (% of total expenses) in Other expenses in 2007?
Keep it short and to the point. 12.66. What is the difference between the Expenses (% of total expenses) in Goods and services in 2002 and the Expenses (% of total expenses) in Subsidies and Transfers in 2007?
Offer a terse response. 19.73. What is the difference between the Expenses (% of total expenses) in Goods and services in 2002 and the Expenses (% of total expenses) in Other expenses in 2007?
Give a very brief answer. 24.92. What is the difference between the Expenses (% of total expenses) of Subsidies and Transfers in 2002 and the Expenses (% of total expenses) of Other expenses in 2007?
Offer a very short reply. 42.31. What is the difference between the Expenses (% of total expenses) in Compensation of employees in 2002 and the Expenses (% of total expenses) in Goods and services in 2008?
Offer a very short reply. 0.44. What is the difference between the Expenses (% of total expenses) of Compensation of employees in 2002 and the Expenses (% of total expenses) of Subsidies and Transfers in 2008?
Keep it short and to the point. -44.11. What is the difference between the Expenses (% of total expenses) in Compensation of employees in 2002 and the Expenses (% of total expenses) in Other expenses in 2008?
Your answer should be very brief. 13.09. What is the difference between the Expenses (% of total expenses) in Goods and services in 2002 and the Expenses (% of total expenses) in Subsidies and Transfers in 2008?
Provide a short and direct response. -31.85. What is the difference between the Expenses (% of total expenses) of Goods and services in 2002 and the Expenses (% of total expenses) of Other expenses in 2008?
Offer a very short reply. 25.34. What is the difference between the Expenses (% of total expenses) in Subsidies and Transfers in 2002 and the Expenses (% of total expenses) in Other expenses in 2008?
Offer a very short reply. 42.74. What is the difference between the Expenses (% of total expenses) of Compensation of employees in 2003 and the Expenses (% of total expenses) of Goods and services in 2004?
Make the answer very short. -6.19. What is the difference between the Expenses (% of total expenses) in Compensation of employees in 2003 and the Expenses (% of total expenses) in Subsidies and Transfers in 2004?
Keep it short and to the point. -22.2. What is the difference between the Expenses (% of total expenses) in Compensation of employees in 2003 and the Expenses (% of total expenses) in Other expenses in 2004?
Provide a short and direct response. -3.12. What is the difference between the Expenses (% of total expenses) of Goods and services in 2003 and the Expenses (% of total expenses) of Subsidies and Transfers in 2004?
Make the answer very short. -20.72. What is the difference between the Expenses (% of total expenses) of Goods and services in 2003 and the Expenses (% of total expenses) of Other expenses in 2004?
Your answer should be compact. -1.64. What is the difference between the Expenses (% of total expenses) of Subsidies and Transfers in 2003 and the Expenses (% of total expenses) of Other expenses in 2004?
Offer a terse response. 25.19. What is the difference between the Expenses (% of total expenses) of Compensation of employees in 2003 and the Expenses (% of total expenses) of Goods and services in 2005?
Make the answer very short. -1.87. What is the difference between the Expenses (% of total expenses) in Compensation of employees in 2003 and the Expenses (% of total expenses) in Subsidies and Transfers in 2005?
Your response must be concise. -24.8. What is the difference between the Expenses (% of total expenses) in Compensation of employees in 2003 and the Expenses (% of total expenses) in Other expenses in 2005?
Your answer should be very brief. 16.91. What is the difference between the Expenses (% of total expenses) of Goods and services in 2003 and the Expenses (% of total expenses) of Subsidies and Transfers in 2005?
Offer a very short reply. -23.32. What is the difference between the Expenses (% of total expenses) in Goods and services in 2003 and the Expenses (% of total expenses) in Other expenses in 2005?
Make the answer very short. 18.39. What is the difference between the Expenses (% of total expenses) of Subsidies and Transfers in 2003 and the Expenses (% of total expenses) of Other expenses in 2005?
Make the answer very short. 45.23. What is the difference between the Expenses (% of total expenses) in Compensation of employees in 2003 and the Expenses (% of total expenses) in Goods and services in 2006?
Provide a succinct answer. -17.21. What is the difference between the Expenses (% of total expenses) of Compensation of employees in 2003 and the Expenses (% of total expenses) of Subsidies and Transfers in 2006?
Keep it short and to the point. -8.21. What is the difference between the Expenses (% of total expenses) in Compensation of employees in 2003 and the Expenses (% of total expenses) in Other expenses in 2006?
Offer a very short reply. 6.54. What is the difference between the Expenses (% of total expenses) of Goods and services in 2003 and the Expenses (% of total expenses) of Subsidies and Transfers in 2006?
Your answer should be very brief. -6.73. What is the difference between the Expenses (% of total expenses) in Goods and services in 2003 and the Expenses (% of total expenses) in Other expenses in 2006?
Keep it short and to the point. 8.02. What is the difference between the Expenses (% of total expenses) of Subsidies and Transfers in 2003 and the Expenses (% of total expenses) of Other expenses in 2006?
Offer a terse response. 34.85. What is the difference between the Expenses (% of total expenses) in Compensation of employees in 2003 and the Expenses (% of total expenses) in Goods and services in 2007?
Your answer should be compact. -18.34. What is the difference between the Expenses (% of total expenses) of Compensation of employees in 2003 and the Expenses (% of total expenses) of Subsidies and Transfers in 2007?
Provide a succinct answer. 8.35. What is the difference between the Expenses (% of total expenses) of Compensation of employees in 2003 and the Expenses (% of total expenses) of Other expenses in 2007?
Your response must be concise. 13.54. What is the difference between the Expenses (% of total expenses) of Goods and services in 2003 and the Expenses (% of total expenses) of Subsidies and Transfers in 2007?
Provide a short and direct response. 9.83. What is the difference between the Expenses (% of total expenses) of Goods and services in 2003 and the Expenses (% of total expenses) of Other expenses in 2007?
Your response must be concise. 15.02. What is the difference between the Expenses (% of total expenses) of Subsidies and Transfers in 2003 and the Expenses (% of total expenses) of Other expenses in 2007?
Ensure brevity in your answer.  41.86. What is the difference between the Expenses (% of total expenses) of Compensation of employees in 2003 and the Expenses (% of total expenses) of Goods and services in 2008?
Make the answer very short. 1.32. What is the difference between the Expenses (% of total expenses) in Compensation of employees in 2003 and the Expenses (% of total expenses) in Subsidies and Transfers in 2008?
Provide a short and direct response. -43.23. What is the difference between the Expenses (% of total expenses) in Compensation of employees in 2003 and the Expenses (% of total expenses) in Other expenses in 2008?
Make the answer very short. 13.97. What is the difference between the Expenses (% of total expenses) in Goods and services in 2003 and the Expenses (% of total expenses) in Subsidies and Transfers in 2008?
Your answer should be very brief. -41.75. What is the difference between the Expenses (% of total expenses) in Goods and services in 2003 and the Expenses (% of total expenses) in Other expenses in 2008?
Provide a succinct answer. 15.45. What is the difference between the Expenses (% of total expenses) in Subsidies and Transfers in 2003 and the Expenses (% of total expenses) in Other expenses in 2008?
Offer a very short reply. 42.28. What is the difference between the Expenses (% of total expenses) of Compensation of employees in 2004 and the Expenses (% of total expenses) of Goods and services in 2005?
Provide a short and direct response. -5.07. What is the difference between the Expenses (% of total expenses) in Compensation of employees in 2004 and the Expenses (% of total expenses) in Subsidies and Transfers in 2005?
Ensure brevity in your answer.  -28.01. What is the difference between the Expenses (% of total expenses) in Compensation of employees in 2004 and the Expenses (% of total expenses) in Other expenses in 2005?
Ensure brevity in your answer.  13.7. What is the difference between the Expenses (% of total expenses) of Goods and services in 2004 and the Expenses (% of total expenses) of Subsidies and Transfers in 2005?
Keep it short and to the point. -18.61. What is the difference between the Expenses (% of total expenses) in Goods and services in 2004 and the Expenses (% of total expenses) in Other expenses in 2005?
Your response must be concise. 23.11. What is the difference between the Expenses (% of total expenses) of Subsidies and Transfers in 2004 and the Expenses (% of total expenses) of Other expenses in 2005?
Your answer should be very brief. 39.11. What is the difference between the Expenses (% of total expenses) of Compensation of employees in 2004 and the Expenses (% of total expenses) of Goods and services in 2006?
Provide a short and direct response. -20.42. What is the difference between the Expenses (% of total expenses) in Compensation of employees in 2004 and the Expenses (% of total expenses) in Subsidies and Transfers in 2006?
Make the answer very short. -11.41. What is the difference between the Expenses (% of total expenses) of Compensation of employees in 2004 and the Expenses (% of total expenses) of Other expenses in 2006?
Your answer should be very brief. 3.33. What is the difference between the Expenses (% of total expenses) of Goods and services in 2004 and the Expenses (% of total expenses) of Subsidies and Transfers in 2006?
Keep it short and to the point. -2.01. What is the difference between the Expenses (% of total expenses) in Goods and services in 2004 and the Expenses (% of total expenses) in Other expenses in 2006?
Provide a short and direct response. 12.73. What is the difference between the Expenses (% of total expenses) in Subsidies and Transfers in 2004 and the Expenses (% of total expenses) in Other expenses in 2006?
Keep it short and to the point. 28.74. What is the difference between the Expenses (% of total expenses) of Compensation of employees in 2004 and the Expenses (% of total expenses) of Goods and services in 2007?
Provide a short and direct response. -21.54. What is the difference between the Expenses (% of total expenses) in Compensation of employees in 2004 and the Expenses (% of total expenses) in Subsidies and Transfers in 2007?
Provide a succinct answer. 5.15. What is the difference between the Expenses (% of total expenses) of Compensation of employees in 2004 and the Expenses (% of total expenses) of Other expenses in 2007?
Offer a terse response. 10.34. What is the difference between the Expenses (% of total expenses) of Goods and services in 2004 and the Expenses (% of total expenses) of Subsidies and Transfers in 2007?
Offer a very short reply. 14.55. What is the difference between the Expenses (% of total expenses) in Goods and services in 2004 and the Expenses (% of total expenses) in Other expenses in 2007?
Give a very brief answer. 19.74. What is the difference between the Expenses (% of total expenses) of Subsidies and Transfers in 2004 and the Expenses (% of total expenses) of Other expenses in 2007?
Your answer should be compact. 35.75. What is the difference between the Expenses (% of total expenses) in Compensation of employees in 2004 and the Expenses (% of total expenses) in Goods and services in 2008?
Keep it short and to the point. -1.89. What is the difference between the Expenses (% of total expenses) in Compensation of employees in 2004 and the Expenses (% of total expenses) in Subsidies and Transfers in 2008?
Give a very brief answer. -46.44. What is the difference between the Expenses (% of total expenses) of Compensation of employees in 2004 and the Expenses (% of total expenses) of Other expenses in 2008?
Offer a terse response. 10.76. What is the difference between the Expenses (% of total expenses) of Goods and services in 2004 and the Expenses (% of total expenses) of Subsidies and Transfers in 2008?
Offer a very short reply. -37.04. What is the difference between the Expenses (% of total expenses) of Goods and services in 2004 and the Expenses (% of total expenses) of Other expenses in 2008?
Your answer should be very brief. 20.16. What is the difference between the Expenses (% of total expenses) in Subsidies and Transfers in 2004 and the Expenses (% of total expenses) in Other expenses in 2008?
Ensure brevity in your answer.  36.17. What is the difference between the Expenses (% of total expenses) in Compensation of employees in 2005 and the Expenses (% of total expenses) in Goods and services in 2006?
Make the answer very short. -21.83. What is the difference between the Expenses (% of total expenses) of Compensation of employees in 2005 and the Expenses (% of total expenses) of Subsidies and Transfers in 2006?
Offer a very short reply. -12.82. What is the difference between the Expenses (% of total expenses) in Compensation of employees in 2005 and the Expenses (% of total expenses) in Other expenses in 2006?
Your answer should be compact. 1.92. What is the difference between the Expenses (% of total expenses) in Goods and services in 2005 and the Expenses (% of total expenses) in Subsidies and Transfers in 2006?
Keep it short and to the point. -6.34. What is the difference between the Expenses (% of total expenses) in Goods and services in 2005 and the Expenses (% of total expenses) in Other expenses in 2006?
Your answer should be compact. 8.4. What is the difference between the Expenses (% of total expenses) in Subsidies and Transfers in 2005 and the Expenses (% of total expenses) in Other expenses in 2006?
Offer a very short reply. 31.34. What is the difference between the Expenses (% of total expenses) of Compensation of employees in 2005 and the Expenses (% of total expenses) of Goods and services in 2007?
Make the answer very short. -22.95. What is the difference between the Expenses (% of total expenses) of Compensation of employees in 2005 and the Expenses (% of total expenses) of Subsidies and Transfers in 2007?
Your response must be concise. 3.74. What is the difference between the Expenses (% of total expenses) in Compensation of employees in 2005 and the Expenses (% of total expenses) in Other expenses in 2007?
Your answer should be very brief. 8.93. What is the difference between the Expenses (% of total expenses) of Goods and services in 2005 and the Expenses (% of total expenses) of Subsidies and Transfers in 2007?
Your response must be concise. 10.22. What is the difference between the Expenses (% of total expenses) of Goods and services in 2005 and the Expenses (% of total expenses) of Other expenses in 2007?
Offer a terse response. 15.41. What is the difference between the Expenses (% of total expenses) of Subsidies and Transfers in 2005 and the Expenses (% of total expenses) of Other expenses in 2007?
Keep it short and to the point. 38.34. What is the difference between the Expenses (% of total expenses) of Compensation of employees in 2005 and the Expenses (% of total expenses) of Goods and services in 2008?
Your response must be concise. -3.3. What is the difference between the Expenses (% of total expenses) in Compensation of employees in 2005 and the Expenses (% of total expenses) in Subsidies and Transfers in 2008?
Offer a terse response. -47.85. What is the difference between the Expenses (% of total expenses) in Compensation of employees in 2005 and the Expenses (% of total expenses) in Other expenses in 2008?
Provide a succinct answer. 9.35. What is the difference between the Expenses (% of total expenses) of Goods and services in 2005 and the Expenses (% of total expenses) of Subsidies and Transfers in 2008?
Offer a very short reply. -41.37. What is the difference between the Expenses (% of total expenses) in Goods and services in 2005 and the Expenses (% of total expenses) in Other expenses in 2008?
Your answer should be very brief. 15.83. What is the difference between the Expenses (% of total expenses) of Subsidies and Transfers in 2005 and the Expenses (% of total expenses) of Other expenses in 2008?
Your answer should be very brief. 38.77. What is the difference between the Expenses (% of total expenses) of Compensation of employees in 2006 and the Expenses (% of total expenses) of Goods and services in 2007?
Keep it short and to the point. -13.91. What is the difference between the Expenses (% of total expenses) in Compensation of employees in 2006 and the Expenses (% of total expenses) in Subsidies and Transfers in 2007?
Give a very brief answer. 12.78. What is the difference between the Expenses (% of total expenses) of Compensation of employees in 2006 and the Expenses (% of total expenses) of Other expenses in 2007?
Provide a short and direct response. 17.97. What is the difference between the Expenses (% of total expenses) in Goods and services in 2006 and the Expenses (% of total expenses) in Subsidies and Transfers in 2007?
Give a very brief answer. 25.56. What is the difference between the Expenses (% of total expenses) of Goods and services in 2006 and the Expenses (% of total expenses) of Other expenses in 2007?
Make the answer very short. 30.75. What is the difference between the Expenses (% of total expenses) in Subsidies and Transfers in 2006 and the Expenses (% of total expenses) in Other expenses in 2007?
Keep it short and to the point. 21.75. What is the difference between the Expenses (% of total expenses) in Compensation of employees in 2006 and the Expenses (% of total expenses) in Goods and services in 2008?
Your response must be concise. 5.74. What is the difference between the Expenses (% of total expenses) of Compensation of employees in 2006 and the Expenses (% of total expenses) of Subsidies and Transfers in 2008?
Provide a short and direct response. -38.81. What is the difference between the Expenses (% of total expenses) of Compensation of employees in 2006 and the Expenses (% of total expenses) of Other expenses in 2008?
Offer a very short reply. 18.39. What is the difference between the Expenses (% of total expenses) of Goods and services in 2006 and the Expenses (% of total expenses) of Subsidies and Transfers in 2008?
Keep it short and to the point. -26.02. What is the difference between the Expenses (% of total expenses) of Goods and services in 2006 and the Expenses (% of total expenses) of Other expenses in 2008?
Your answer should be compact. 31.18. What is the difference between the Expenses (% of total expenses) of Subsidies and Transfers in 2006 and the Expenses (% of total expenses) of Other expenses in 2008?
Make the answer very short. 22.17. What is the difference between the Expenses (% of total expenses) of Compensation of employees in 2007 and the Expenses (% of total expenses) of Goods and services in 2008?
Keep it short and to the point. 11.83. What is the difference between the Expenses (% of total expenses) in Compensation of employees in 2007 and the Expenses (% of total expenses) in Subsidies and Transfers in 2008?
Your answer should be compact. -32.72. What is the difference between the Expenses (% of total expenses) of Compensation of employees in 2007 and the Expenses (% of total expenses) of Other expenses in 2008?
Offer a terse response. 24.48. What is the difference between the Expenses (% of total expenses) of Goods and services in 2007 and the Expenses (% of total expenses) of Subsidies and Transfers in 2008?
Ensure brevity in your answer.  -24.9. What is the difference between the Expenses (% of total expenses) of Goods and services in 2007 and the Expenses (% of total expenses) of Other expenses in 2008?
Ensure brevity in your answer.  32.3. What is the difference between the Expenses (% of total expenses) in Subsidies and Transfers in 2007 and the Expenses (% of total expenses) in Other expenses in 2008?
Your response must be concise. 5.61. What is the average Expenses (% of total expenses) in Compensation of employees per year?
Offer a very short reply. 18.76. What is the average Expenses (% of total expenses) of Goods and services per year?
Your response must be concise. 26.46. What is the average Expenses (% of total expenses) in Subsidies and Transfers per year?
Your answer should be very brief. 38.63. What is the average Expenses (% of total expenses) of Other expenses per year?
Provide a succinct answer. 7.24. In the year 1999, what is the difference between the Expenses (% of total expenses) of Compensation of employees and Expenses (% of total expenses) of Goods and services?
Your answer should be very brief. -20.42. In the year 1999, what is the difference between the Expenses (% of total expenses) of Compensation of employees and Expenses (% of total expenses) of Subsidies and Transfers?
Offer a very short reply. -16.1. In the year 1999, what is the difference between the Expenses (% of total expenses) in Compensation of employees and Expenses (% of total expenses) in Other expenses?
Offer a terse response. 21.52. In the year 1999, what is the difference between the Expenses (% of total expenses) of Goods and services and Expenses (% of total expenses) of Subsidies and Transfers?
Ensure brevity in your answer.  4.32. In the year 1999, what is the difference between the Expenses (% of total expenses) of Goods and services and Expenses (% of total expenses) of Other expenses?
Offer a terse response. 41.94. In the year 1999, what is the difference between the Expenses (% of total expenses) of Subsidies and Transfers and Expenses (% of total expenses) of Other expenses?
Offer a terse response. 37.62. In the year 2001, what is the difference between the Expenses (% of total expenses) in Compensation of employees and Expenses (% of total expenses) in Goods and services?
Ensure brevity in your answer.  1.2. In the year 2001, what is the difference between the Expenses (% of total expenses) in Compensation of employees and Expenses (% of total expenses) in Subsidies and Transfers?
Your answer should be compact. -20.61. In the year 2001, what is the difference between the Expenses (% of total expenses) in Compensation of employees and Expenses (% of total expenses) in Other expenses?
Your response must be concise. 22.04. In the year 2001, what is the difference between the Expenses (% of total expenses) in Goods and services and Expenses (% of total expenses) in Subsidies and Transfers?
Ensure brevity in your answer.  -21.81. In the year 2001, what is the difference between the Expenses (% of total expenses) of Goods and services and Expenses (% of total expenses) of Other expenses?
Keep it short and to the point. 20.84. In the year 2001, what is the difference between the Expenses (% of total expenses) in Subsidies and Transfers and Expenses (% of total expenses) in Other expenses?
Ensure brevity in your answer.  42.65. In the year 2002, what is the difference between the Expenses (% of total expenses) in Compensation of employees and Expenses (% of total expenses) in Goods and services?
Your answer should be very brief. -12.26. In the year 2002, what is the difference between the Expenses (% of total expenses) of Compensation of employees and Expenses (% of total expenses) of Subsidies and Transfers?
Provide a short and direct response. -29.65. In the year 2002, what is the difference between the Expenses (% of total expenses) in Compensation of employees and Expenses (% of total expenses) in Other expenses?
Your answer should be compact. 5.47. In the year 2002, what is the difference between the Expenses (% of total expenses) of Goods and services and Expenses (% of total expenses) of Subsidies and Transfers?
Provide a succinct answer. -17.39. In the year 2002, what is the difference between the Expenses (% of total expenses) of Goods and services and Expenses (% of total expenses) of Other expenses?
Provide a short and direct response. 17.73. In the year 2002, what is the difference between the Expenses (% of total expenses) in Subsidies and Transfers and Expenses (% of total expenses) in Other expenses?
Keep it short and to the point. 35.12. In the year 2003, what is the difference between the Expenses (% of total expenses) of Compensation of employees and Expenses (% of total expenses) of Goods and services?
Offer a terse response. -1.48. In the year 2003, what is the difference between the Expenses (% of total expenses) of Compensation of employees and Expenses (% of total expenses) of Subsidies and Transfers?
Offer a very short reply. -28.31. In the year 2003, what is the difference between the Expenses (% of total expenses) in Compensation of employees and Expenses (% of total expenses) in Other expenses?
Offer a terse response. 0.85. In the year 2003, what is the difference between the Expenses (% of total expenses) in Goods and services and Expenses (% of total expenses) in Subsidies and Transfers?
Offer a very short reply. -26.84. In the year 2003, what is the difference between the Expenses (% of total expenses) of Goods and services and Expenses (% of total expenses) of Other expenses?
Your answer should be very brief. 2.33. In the year 2003, what is the difference between the Expenses (% of total expenses) in Subsidies and Transfers and Expenses (% of total expenses) in Other expenses?
Provide a short and direct response. 29.16. In the year 2004, what is the difference between the Expenses (% of total expenses) of Compensation of employees and Expenses (% of total expenses) of Goods and services?
Your answer should be very brief. -9.4. In the year 2004, what is the difference between the Expenses (% of total expenses) in Compensation of employees and Expenses (% of total expenses) in Subsidies and Transfers?
Provide a short and direct response. -25.41. In the year 2004, what is the difference between the Expenses (% of total expenses) of Compensation of employees and Expenses (% of total expenses) of Other expenses?
Your answer should be compact. -6.33. In the year 2004, what is the difference between the Expenses (% of total expenses) in Goods and services and Expenses (% of total expenses) in Subsidies and Transfers?
Offer a very short reply. -16.01. In the year 2004, what is the difference between the Expenses (% of total expenses) in Goods and services and Expenses (% of total expenses) in Other expenses?
Your answer should be compact. 3.07. In the year 2004, what is the difference between the Expenses (% of total expenses) of Subsidies and Transfers and Expenses (% of total expenses) of Other expenses?
Your answer should be compact. 19.08. In the year 2005, what is the difference between the Expenses (% of total expenses) of Compensation of employees and Expenses (% of total expenses) of Goods and services?
Provide a short and direct response. -6.48. In the year 2005, what is the difference between the Expenses (% of total expenses) of Compensation of employees and Expenses (% of total expenses) of Subsidies and Transfers?
Provide a short and direct response. -29.42. In the year 2005, what is the difference between the Expenses (% of total expenses) in Compensation of employees and Expenses (% of total expenses) in Other expenses?
Offer a very short reply. 12.29. In the year 2005, what is the difference between the Expenses (% of total expenses) of Goods and services and Expenses (% of total expenses) of Subsidies and Transfers?
Your answer should be compact. -22.93. In the year 2005, what is the difference between the Expenses (% of total expenses) in Goods and services and Expenses (% of total expenses) in Other expenses?
Give a very brief answer. 18.78. In the year 2005, what is the difference between the Expenses (% of total expenses) of Subsidies and Transfers and Expenses (% of total expenses) of Other expenses?
Your answer should be very brief. 41.71. In the year 2006, what is the difference between the Expenses (% of total expenses) in Compensation of employees and Expenses (% of total expenses) in Goods and services?
Make the answer very short. -12.79. In the year 2006, what is the difference between the Expenses (% of total expenses) of Compensation of employees and Expenses (% of total expenses) of Subsidies and Transfers?
Your answer should be very brief. -3.78. In the year 2006, what is the difference between the Expenses (% of total expenses) in Compensation of employees and Expenses (% of total expenses) in Other expenses?
Offer a very short reply. 10.96. In the year 2006, what is the difference between the Expenses (% of total expenses) of Goods and services and Expenses (% of total expenses) of Subsidies and Transfers?
Provide a short and direct response. 9. In the year 2006, what is the difference between the Expenses (% of total expenses) of Goods and services and Expenses (% of total expenses) of Other expenses?
Provide a short and direct response. 23.75. In the year 2006, what is the difference between the Expenses (% of total expenses) in Subsidies and Transfers and Expenses (% of total expenses) in Other expenses?
Make the answer very short. 14.74. In the year 2007, what is the difference between the Expenses (% of total expenses) of Compensation of employees and Expenses (% of total expenses) of Goods and services?
Give a very brief answer. -7.83. In the year 2007, what is the difference between the Expenses (% of total expenses) in Compensation of employees and Expenses (% of total expenses) in Subsidies and Transfers?
Provide a short and direct response. 18.86. In the year 2007, what is the difference between the Expenses (% of total expenses) of Compensation of employees and Expenses (% of total expenses) of Other expenses?
Ensure brevity in your answer.  24.05. In the year 2007, what is the difference between the Expenses (% of total expenses) of Goods and services and Expenses (% of total expenses) of Subsidies and Transfers?
Your response must be concise. 26.69. In the year 2007, what is the difference between the Expenses (% of total expenses) of Goods and services and Expenses (% of total expenses) of Other expenses?
Offer a terse response. 31.88. In the year 2007, what is the difference between the Expenses (% of total expenses) in Subsidies and Transfers and Expenses (% of total expenses) in Other expenses?
Provide a short and direct response. 5.19. In the year 2008, what is the difference between the Expenses (% of total expenses) in Compensation of employees and Expenses (% of total expenses) in Goods and services?
Your response must be concise. 0.21. In the year 2008, what is the difference between the Expenses (% of total expenses) of Compensation of employees and Expenses (% of total expenses) of Subsidies and Transfers?
Offer a very short reply. -44.34. In the year 2008, what is the difference between the Expenses (% of total expenses) of Compensation of employees and Expenses (% of total expenses) of Other expenses?
Your answer should be very brief. 12.86. In the year 2008, what is the difference between the Expenses (% of total expenses) of Goods and services and Expenses (% of total expenses) of Subsidies and Transfers?
Provide a short and direct response. -44.55. In the year 2008, what is the difference between the Expenses (% of total expenses) in Goods and services and Expenses (% of total expenses) in Other expenses?
Keep it short and to the point. 12.65. In the year 2008, what is the difference between the Expenses (% of total expenses) in Subsidies and Transfers and Expenses (% of total expenses) in Other expenses?
Offer a terse response. 57.2. What is the ratio of the Expenses (% of total expenses) of Compensation of employees in 1999 to that in 2001?
Give a very brief answer. 0.93. What is the ratio of the Expenses (% of total expenses) in Goods and services in 1999 to that in 2001?
Keep it short and to the point. 1.91. What is the ratio of the Expenses (% of total expenses) of Subsidies and Transfers in 1999 to that in 2001?
Keep it short and to the point. 0.86. What is the ratio of the Expenses (% of total expenses) in Other expenses in 1999 to that in 2001?
Give a very brief answer. 0.19. What is the ratio of the Expenses (% of total expenses) in Compensation of employees in 1999 to that in 2002?
Provide a short and direct response. 1.35. What is the ratio of the Expenses (% of total expenses) in Goods and services in 1999 to that in 2002?
Your response must be concise. 1.49. What is the ratio of the Expenses (% of total expenses) in Subsidies and Transfers in 1999 to that in 2002?
Your answer should be very brief. 0.83. What is the ratio of the Expenses (% of total expenses) of Other expenses in 1999 to that in 2002?
Provide a short and direct response. 0.02. What is the ratio of the Expenses (% of total expenses) of Compensation of employees in 1999 to that in 2003?
Provide a succinct answer. 1.28. What is the ratio of the Expenses (% of total expenses) in Goods and services in 1999 to that in 2003?
Make the answer very short. 2.29. What is the ratio of the Expenses (% of total expenses) of Subsidies and Transfers in 1999 to that in 2003?
Make the answer very short. 0.84. What is the ratio of the Expenses (% of total expenses) of Other expenses in 1999 to that in 2003?
Provide a short and direct response. 0.01. What is the ratio of the Expenses (% of total expenses) of Compensation of employees in 1999 to that in 2004?
Provide a succinct answer. 1.58. What is the ratio of the Expenses (% of total expenses) in Goods and services in 1999 to that in 2004?
Give a very brief answer. 1.82. What is the ratio of the Expenses (% of total expenses) in Subsidies and Transfers in 1999 to that in 2004?
Your answer should be compact. 0.97. What is the ratio of the Expenses (% of total expenses) in Other expenses in 1999 to that in 2004?
Ensure brevity in your answer.  0.01. What is the ratio of the Expenses (% of total expenses) in Compensation of employees in 1999 to that in 2005?
Give a very brief answer. 1.76. What is the ratio of the Expenses (% of total expenses) in Goods and services in 1999 to that in 2005?
Make the answer very short. 2.24. What is the ratio of the Expenses (% of total expenses) in Subsidies and Transfers in 1999 to that in 2005?
Your answer should be very brief. 0.91. What is the ratio of the Expenses (% of total expenses) of Other expenses in 1999 to that in 2005?
Ensure brevity in your answer.  4.73. What is the ratio of the Expenses (% of total expenses) of Compensation of employees in 1999 to that in 2006?
Give a very brief answer. 1.02. What is the ratio of the Expenses (% of total expenses) in Goods and services in 1999 to that in 2006?
Provide a succinct answer. 1.23. What is the ratio of the Expenses (% of total expenses) in Subsidies and Transfers in 1999 to that in 2006?
Provide a short and direct response. 1.5. What is the ratio of the Expenses (% of total expenses) of Other expenses in 1999 to that in 2006?
Offer a terse response. 0.02. What is the ratio of the Expenses (% of total expenses) in Compensation of employees in 1999 to that in 2007?
Offer a terse response. 0.79. What is the ratio of the Expenses (% of total expenses) in Goods and services in 1999 to that in 2007?
Offer a very short reply. 1.19. What is the ratio of the Expenses (% of total expenses) of Subsidies and Transfers in 1999 to that in 2007?
Your answer should be very brief. 4.4. What is the ratio of the Expenses (% of total expenses) of Other expenses in 1999 to that in 2007?
Ensure brevity in your answer.  0.07. What is the ratio of the Expenses (% of total expenses) in Compensation of employees in 1999 to that in 2008?
Give a very brief answer. 1.37. What is the ratio of the Expenses (% of total expenses) of Goods and services in 1999 to that in 2008?
Your answer should be very brief. 2.7. What is the ratio of the Expenses (% of total expenses) of Subsidies and Transfers in 1999 to that in 2008?
Keep it short and to the point. 0.63. What is the ratio of the Expenses (% of total expenses) in Other expenses in 1999 to that in 2008?
Your response must be concise. 0.08. What is the ratio of the Expenses (% of total expenses) in Compensation of employees in 2001 to that in 2002?
Offer a very short reply. 1.45. What is the ratio of the Expenses (% of total expenses) of Goods and services in 2001 to that in 2002?
Give a very brief answer. 0.78. What is the ratio of the Expenses (% of total expenses) in Subsidies and Transfers in 2001 to that in 2002?
Provide a succinct answer. 0.96. What is the ratio of the Expenses (% of total expenses) of Other expenses in 2001 to that in 2002?
Ensure brevity in your answer.  0.12. What is the ratio of the Expenses (% of total expenses) in Compensation of employees in 2001 to that in 2003?
Give a very brief answer. 1.37. What is the ratio of the Expenses (% of total expenses) of Goods and services in 2001 to that in 2003?
Keep it short and to the point. 1.2. What is the ratio of the Expenses (% of total expenses) in Subsidies and Transfers in 2001 to that in 2003?
Provide a short and direct response. 0.97. What is the ratio of the Expenses (% of total expenses) of Other expenses in 2001 to that in 2003?
Give a very brief answer. 0.08. What is the ratio of the Expenses (% of total expenses) of Compensation of employees in 2001 to that in 2004?
Your response must be concise. 1.69. What is the ratio of the Expenses (% of total expenses) in Goods and services in 2001 to that in 2004?
Your response must be concise. 0.95. What is the ratio of the Expenses (% of total expenses) in Subsidies and Transfers in 2001 to that in 2004?
Provide a succinct answer. 1.12. What is the ratio of the Expenses (% of total expenses) of Other expenses in 2001 to that in 2004?
Provide a succinct answer. 0.06. What is the ratio of the Expenses (% of total expenses) of Compensation of employees in 2001 to that in 2005?
Offer a very short reply. 1.89. What is the ratio of the Expenses (% of total expenses) in Goods and services in 2001 to that in 2005?
Your answer should be compact. 1.17. What is the ratio of the Expenses (% of total expenses) of Subsidies and Transfers in 2001 to that in 2005?
Keep it short and to the point. 1.05. What is the ratio of the Expenses (% of total expenses) of Other expenses in 2001 to that in 2005?
Keep it short and to the point. 25.17. What is the ratio of the Expenses (% of total expenses) of Compensation of employees in 2001 to that in 2006?
Ensure brevity in your answer.  1.09. What is the ratio of the Expenses (% of total expenses) in Goods and services in 2001 to that in 2006?
Offer a very short reply. 0.65. What is the ratio of the Expenses (% of total expenses) in Subsidies and Transfers in 2001 to that in 2006?
Provide a succinct answer. 1.74. What is the ratio of the Expenses (% of total expenses) of Other expenses in 2001 to that in 2006?
Give a very brief answer. 0.12. What is the ratio of the Expenses (% of total expenses) of Compensation of employees in 2001 to that in 2007?
Provide a succinct answer. 0.85. What is the ratio of the Expenses (% of total expenses) in Goods and services in 2001 to that in 2007?
Ensure brevity in your answer.  0.63. What is the ratio of the Expenses (% of total expenses) in Subsidies and Transfers in 2001 to that in 2007?
Give a very brief answer. 5.1. What is the ratio of the Expenses (% of total expenses) of Other expenses in 2001 to that in 2007?
Your answer should be very brief. 0.36. What is the ratio of the Expenses (% of total expenses) in Compensation of employees in 2001 to that in 2008?
Ensure brevity in your answer.  1.47. What is the ratio of the Expenses (% of total expenses) of Goods and services in 2001 to that in 2008?
Offer a very short reply. 1.41. What is the ratio of the Expenses (% of total expenses) in Subsidies and Transfers in 2001 to that in 2008?
Provide a short and direct response. 0.73. What is the ratio of the Expenses (% of total expenses) in Other expenses in 2001 to that in 2008?
Keep it short and to the point. 0.41. What is the ratio of the Expenses (% of total expenses) in Compensation of employees in 2002 to that in 2003?
Ensure brevity in your answer.  0.95. What is the ratio of the Expenses (% of total expenses) in Goods and services in 2002 to that in 2003?
Make the answer very short. 1.54. What is the ratio of the Expenses (% of total expenses) of Other expenses in 2002 to that in 2003?
Your response must be concise. 0.66. What is the ratio of the Expenses (% of total expenses) in Compensation of employees in 2002 to that in 2004?
Offer a terse response. 1.17. What is the ratio of the Expenses (% of total expenses) in Goods and services in 2002 to that in 2004?
Provide a succinct answer. 1.22. What is the ratio of the Expenses (% of total expenses) of Subsidies and Transfers in 2002 to that in 2004?
Offer a very short reply. 1.17. What is the ratio of the Expenses (% of total expenses) of Other expenses in 2002 to that in 2004?
Provide a succinct answer. 0.53. What is the ratio of the Expenses (% of total expenses) in Compensation of employees in 2002 to that in 2005?
Ensure brevity in your answer.  1.3. What is the ratio of the Expenses (% of total expenses) of Goods and services in 2002 to that in 2005?
Provide a succinct answer. 1.51. What is the ratio of the Expenses (% of total expenses) in Subsidies and Transfers in 2002 to that in 2005?
Ensure brevity in your answer.  1.1. What is the ratio of the Expenses (% of total expenses) in Other expenses in 2002 to that in 2005?
Offer a terse response. 215.98. What is the ratio of the Expenses (% of total expenses) in Compensation of employees in 2002 to that in 2006?
Provide a succinct answer. 0.75. What is the ratio of the Expenses (% of total expenses) in Goods and services in 2002 to that in 2006?
Ensure brevity in your answer.  0.83. What is the ratio of the Expenses (% of total expenses) in Subsidies and Transfers in 2002 to that in 2006?
Give a very brief answer. 1.82. What is the ratio of the Expenses (% of total expenses) of Other expenses in 2002 to that in 2006?
Your answer should be compact. 1.02. What is the ratio of the Expenses (% of total expenses) of Compensation of employees in 2002 to that in 2007?
Give a very brief answer. 0.59. What is the ratio of the Expenses (% of total expenses) of Goods and services in 2002 to that in 2007?
Give a very brief answer. 0.8. What is the ratio of the Expenses (% of total expenses) in Subsidies and Transfers in 2002 to that in 2007?
Ensure brevity in your answer.  5.31. What is the ratio of the Expenses (% of total expenses) in Other expenses in 2002 to that in 2007?
Ensure brevity in your answer.  3.11. What is the ratio of the Expenses (% of total expenses) in Compensation of employees in 2002 to that in 2008?
Give a very brief answer. 1.01. What is the ratio of the Expenses (% of total expenses) in Goods and services in 2002 to that in 2008?
Give a very brief answer. 1.81. What is the ratio of the Expenses (% of total expenses) of Subsidies and Transfers in 2002 to that in 2008?
Your answer should be very brief. 0.76. What is the ratio of the Expenses (% of total expenses) of Other expenses in 2002 to that in 2008?
Offer a terse response. 3.54. What is the ratio of the Expenses (% of total expenses) in Compensation of employees in 2003 to that in 2004?
Ensure brevity in your answer.  1.23. What is the ratio of the Expenses (% of total expenses) of Goods and services in 2003 to that in 2004?
Your answer should be very brief. 0.8. What is the ratio of the Expenses (% of total expenses) of Subsidies and Transfers in 2003 to that in 2004?
Make the answer very short. 1.16. What is the ratio of the Expenses (% of total expenses) in Other expenses in 2003 to that in 2004?
Make the answer very short. 0.8. What is the ratio of the Expenses (% of total expenses) in Compensation of employees in 2003 to that in 2005?
Keep it short and to the point. 1.37. What is the ratio of the Expenses (% of total expenses) of Goods and services in 2003 to that in 2005?
Provide a succinct answer. 0.98. What is the ratio of the Expenses (% of total expenses) in Subsidies and Transfers in 2003 to that in 2005?
Give a very brief answer. 1.08. What is the ratio of the Expenses (% of total expenses) in Other expenses in 2003 to that in 2005?
Give a very brief answer. 327.99. What is the ratio of the Expenses (% of total expenses) of Compensation of employees in 2003 to that in 2006?
Your answer should be very brief. 0.79. What is the ratio of the Expenses (% of total expenses) in Goods and services in 2003 to that in 2006?
Give a very brief answer. 0.54. What is the ratio of the Expenses (% of total expenses) of Subsidies and Transfers in 2003 to that in 2006?
Offer a very short reply. 1.8. What is the ratio of the Expenses (% of total expenses) of Other expenses in 2003 to that in 2006?
Ensure brevity in your answer.  1.55. What is the ratio of the Expenses (% of total expenses) in Compensation of employees in 2003 to that in 2007?
Provide a succinct answer. 0.62. What is the ratio of the Expenses (% of total expenses) of Goods and services in 2003 to that in 2007?
Your answer should be compact. 0.52. What is the ratio of the Expenses (% of total expenses) in Subsidies and Transfers in 2003 to that in 2007?
Ensure brevity in your answer.  5.26. What is the ratio of the Expenses (% of total expenses) of Other expenses in 2003 to that in 2007?
Give a very brief answer. 4.72. What is the ratio of the Expenses (% of total expenses) of Compensation of employees in 2003 to that in 2008?
Keep it short and to the point. 1.07. What is the ratio of the Expenses (% of total expenses) in Goods and services in 2003 to that in 2008?
Provide a succinct answer. 1.18. What is the ratio of the Expenses (% of total expenses) in Subsidies and Transfers in 2003 to that in 2008?
Provide a short and direct response. 0.75. What is the ratio of the Expenses (% of total expenses) of Other expenses in 2003 to that in 2008?
Offer a very short reply. 5.38. What is the ratio of the Expenses (% of total expenses) in Compensation of employees in 2004 to that in 2005?
Provide a succinct answer. 1.11. What is the ratio of the Expenses (% of total expenses) in Goods and services in 2004 to that in 2005?
Provide a succinct answer. 1.23. What is the ratio of the Expenses (% of total expenses) in Subsidies and Transfers in 2004 to that in 2005?
Provide a succinct answer. 0.94. What is the ratio of the Expenses (% of total expenses) of Other expenses in 2004 to that in 2005?
Keep it short and to the point. 408.82. What is the ratio of the Expenses (% of total expenses) of Compensation of employees in 2004 to that in 2006?
Offer a terse response. 0.64. What is the ratio of the Expenses (% of total expenses) of Goods and services in 2004 to that in 2006?
Offer a terse response. 0.68. What is the ratio of the Expenses (% of total expenses) in Subsidies and Transfers in 2004 to that in 2006?
Keep it short and to the point. 1.56. What is the ratio of the Expenses (% of total expenses) in Other expenses in 2004 to that in 2006?
Your answer should be very brief. 1.93. What is the ratio of the Expenses (% of total expenses) of Compensation of employees in 2004 to that in 2007?
Offer a terse response. 0.5. What is the ratio of the Expenses (% of total expenses) in Goods and services in 2004 to that in 2007?
Keep it short and to the point. 0.66. What is the ratio of the Expenses (% of total expenses) in Subsidies and Transfers in 2004 to that in 2007?
Offer a terse response. 4.55. What is the ratio of the Expenses (% of total expenses) of Other expenses in 2004 to that in 2007?
Keep it short and to the point. 5.88. What is the ratio of the Expenses (% of total expenses) of Compensation of employees in 2004 to that in 2008?
Your answer should be very brief. 0.87. What is the ratio of the Expenses (% of total expenses) in Goods and services in 2004 to that in 2008?
Provide a short and direct response. 1.48. What is the ratio of the Expenses (% of total expenses) in Subsidies and Transfers in 2004 to that in 2008?
Make the answer very short. 0.65. What is the ratio of the Expenses (% of total expenses) in Other expenses in 2004 to that in 2008?
Make the answer very short. 6.71. What is the ratio of the Expenses (% of total expenses) of Compensation of employees in 2005 to that in 2006?
Make the answer very short. 0.58. What is the ratio of the Expenses (% of total expenses) of Goods and services in 2005 to that in 2006?
Keep it short and to the point. 0.55. What is the ratio of the Expenses (% of total expenses) of Subsidies and Transfers in 2005 to that in 2006?
Your answer should be compact. 1.66. What is the ratio of the Expenses (% of total expenses) of Other expenses in 2005 to that in 2006?
Your response must be concise. 0. What is the ratio of the Expenses (% of total expenses) of Compensation of employees in 2005 to that in 2007?
Keep it short and to the point. 0.45. What is the ratio of the Expenses (% of total expenses) in Goods and services in 2005 to that in 2007?
Give a very brief answer. 0.53. What is the ratio of the Expenses (% of total expenses) of Subsidies and Transfers in 2005 to that in 2007?
Provide a short and direct response. 4.85. What is the ratio of the Expenses (% of total expenses) of Other expenses in 2005 to that in 2007?
Ensure brevity in your answer.  0.01. What is the ratio of the Expenses (% of total expenses) in Compensation of employees in 2005 to that in 2008?
Make the answer very short. 0.78. What is the ratio of the Expenses (% of total expenses) in Goods and services in 2005 to that in 2008?
Offer a terse response. 1.2. What is the ratio of the Expenses (% of total expenses) in Subsidies and Transfers in 2005 to that in 2008?
Offer a terse response. 0.69. What is the ratio of the Expenses (% of total expenses) of Other expenses in 2005 to that in 2008?
Ensure brevity in your answer.  0.02. What is the ratio of the Expenses (% of total expenses) in Compensation of employees in 2006 to that in 2007?
Your response must be concise. 0.78. What is the ratio of the Expenses (% of total expenses) of Goods and services in 2006 to that in 2007?
Keep it short and to the point. 0.97. What is the ratio of the Expenses (% of total expenses) of Subsidies and Transfers in 2006 to that in 2007?
Provide a short and direct response. 2.92. What is the ratio of the Expenses (% of total expenses) in Other expenses in 2006 to that in 2007?
Make the answer very short. 3.05. What is the ratio of the Expenses (% of total expenses) in Compensation of employees in 2006 to that in 2008?
Offer a terse response. 1.35. What is the ratio of the Expenses (% of total expenses) of Goods and services in 2006 to that in 2008?
Provide a succinct answer. 2.18. What is the ratio of the Expenses (% of total expenses) in Subsidies and Transfers in 2006 to that in 2008?
Make the answer very short. 0.42. What is the ratio of the Expenses (% of total expenses) of Other expenses in 2006 to that in 2008?
Ensure brevity in your answer.  3.48. What is the ratio of the Expenses (% of total expenses) in Compensation of employees in 2007 to that in 2008?
Provide a succinct answer. 1.73. What is the ratio of the Expenses (% of total expenses) of Goods and services in 2007 to that in 2008?
Your response must be concise. 2.26. What is the ratio of the Expenses (% of total expenses) of Subsidies and Transfers in 2007 to that in 2008?
Make the answer very short. 0.14. What is the ratio of the Expenses (% of total expenses) in Other expenses in 2007 to that in 2008?
Provide a short and direct response. 1.14. What is the difference between the highest and the second highest Expenses (% of total expenses) of Compensation of employees?
Offer a very short reply. 4.19. What is the difference between the highest and the second highest Expenses (% of total expenses) of Goods and services?
Provide a short and direct response. 6.88. What is the difference between the highest and the second highest Expenses (% of total expenses) of Subsidies and Transfers?
Provide a short and direct response. 14.46. What is the difference between the highest and the second highest Expenses (% of total expenses) in Other expenses?
Your response must be concise. 3.97. What is the difference between the highest and the lowest Expenses (% of total expenses) of Compensation of employees?
Your answer should be very brief. 15.13. What is the difference between the highest and the lowest Expenses (% of total expenses) in Goods and services?
Provide a succinct answer. 26.53. What is the difference between the highest and the lowest Expenses (% of total expenses) in Subsidies and Transfers?
Provide a short and direct response. 51.59. What is the difference between the highest and the lowest Expenses (% of total expenses) in Other expenses?
Keep it short and to the point. 20.03. 